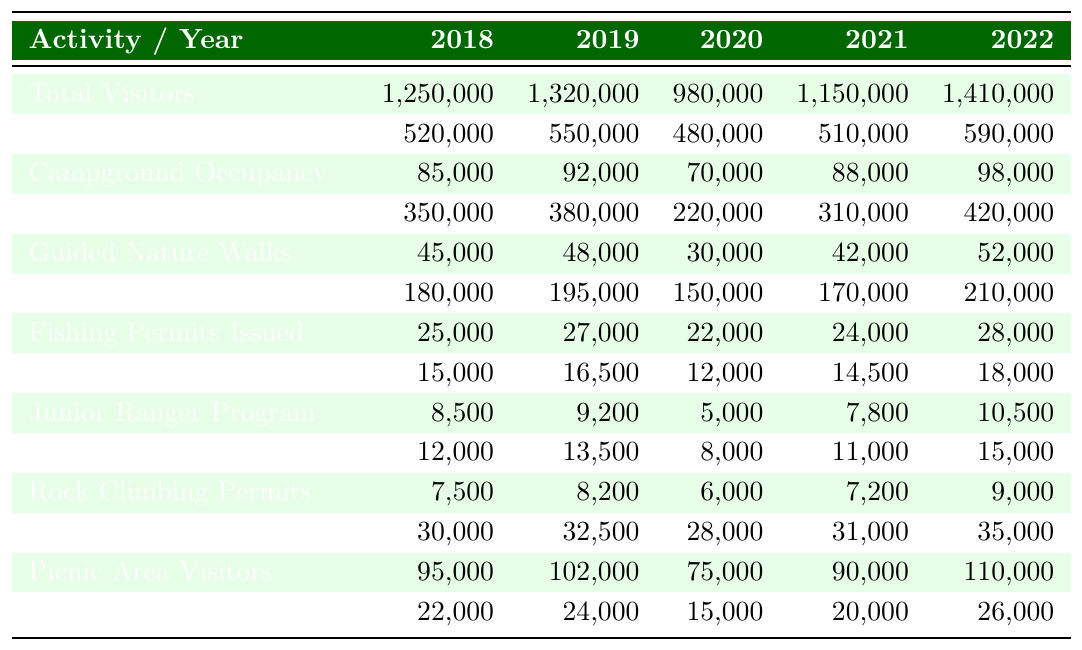What was the total number of visitors in 2022? The table shows that the Total Visitors for the year 2022 is reported as 1,410,000.
Answer: 1,410,000 How many fishing permits were issued in 2020? According to the table, the Fishing Permits Issued in 2020 total 22,000.
Answer: 22,000 Between 2018 and 2022, which year had the highest campground occupancy? The highest campground occupancy from 2018 to 2022 is found in 2022, with a total of 98,000.
Answer: 2022 What is the average number of visitors to the Visitor Center from 2018 to 2022? To calculate the average, sum the Visitor Center Attendance values: 350,000 + 380,000 + 220,000 + 310,000 + 420,000 = 1,680,000. Then divide by 5 (the number of years): 1,680,000 / 5 = 336,000.
Answer: 336,000 Did the attendance for Junior Ranger Programs increase every year from 2018 to 2022? Reviewing the Junior Ranger Program Participants from each year shows: 8,500 (2018), 9,200 (2019), 5,000 (2020), 7,800 (2021), and 10,500 (2022). Since there is a decrease in 2020, the statement is false.
Answer: No What was the percentage increase in total visitors from 2018 to 2022? Total visitors in 2018 were 1,250,000 and in 2022 were 1,410,000. The difference is 1,410,000 - 1,250,000 = 160,000. To find the percentage increase: (160,000 / 1,250,000) * 100 = 12.8%.
Answer: 12.8% Which activity had the highest attendance in 2021? The table indicates that Visitor Center Attendance was the highest in 2021, with 310,000 visitors.
Answer: Visitor Center Attendance What is the total number of visitors for hiking trails across all years? By summing the Hiking Trails values: 520,000 + 550,000 + 480,000 + 510,000 + 590,000 = 2,650,000.
Answer: 2,650,000 Was there a decline in attendance for stargazing events from 2019 to 2020? The stargazing attendance was 13,500 in 2019 and fell to 8,000 in 2020. This indicates a decline in attendance.
Answer: Yes What was the average campground occupancy from 2018 to 2022? Summing the Campground Occupancy values gives 85,000 + 92,000 + 70,000 + 88,000 + 98,000 = 433,000. To find the average, divide by 5: 433,000 / 5 = 86,600.
Answer: 86,600 Which year saw the lowest number of guided nature walks? Guided Nature Walks are lowest in 2020, with only 30,000 participants.
Answer: 2020 